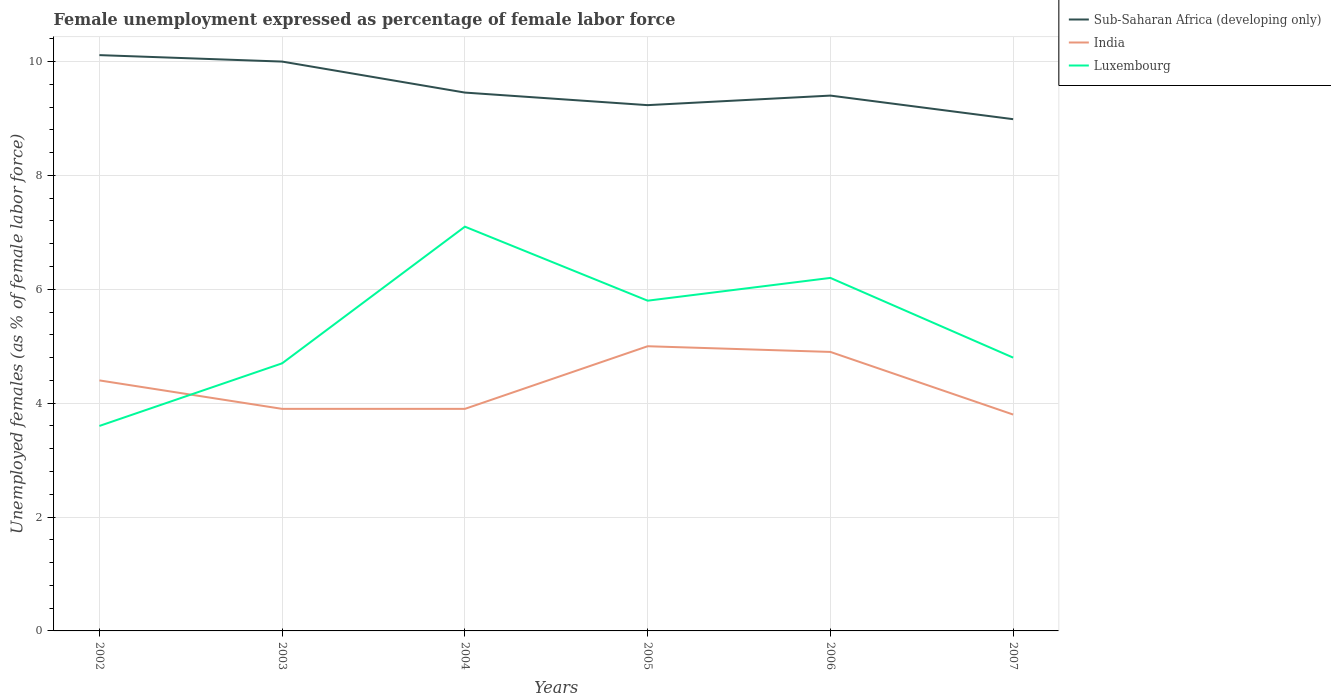Across all years, what is the maximum unemployment in females in in India?
Provide a succinct answer. 3.8. What is the total unemployment in females in in India in the graph?
Offer a very short reply. 0.5. What is the difference between the highest and the second highest unemployment in females in in Luxembourg?
Keep it short and to the point. 3.5. What is the difference between the highest and the lowest unemployment in females in in Luxembourg?
Your response must be concise. 3. Is the unemployment in females in in India strictly greater than the unemployment in females in in Sub-Saharan Africa (developing only) over the years?
Make the answer very short. Yes. How many lines are there?
Give a very brief answer. 3. How many years are there in the graph?
Ensure brevity in your answer.  6. Does the graph contain grids?
Your answer should be compact. Yes. Where does the legend appear in the graph?
Your answer should be very brief. Top right. How are the legend labels stacked?
Your answer should be compact. Vertical. What is the title of the graph?
Offer a terse response. Female unemployment expressed as percentage of female labor force. Does "Trinidad and Tobago" appear as one of the legend labels in the graph?
Offer a terse response. No. What is the label or title of the Y-axis?
Offer a very short reply. Unemployed females (as % of female labor force). What is the Unemployed females (as % of female labor force) in Sub-Saharan Africa (developing only) in 2002?
Provide a succinct answer. 10.11. What is the Unemployed females (as % of female labor force) of India in 2002?
Keep it short and to the point. 4.4. What is the Unemployed females (as % of female labor force) in Luxembourg in 2002?
Provide a short and direct response. 3.6. What is the Unemployed females (as % of female labor force) in Sub-Saharan Africa (developing only) in 2003?
Offer a very short reply. 10. What is the Unemployed females (as % of female labor force) in India in 2003?
Provide a short and direct response. 3.9. What is the Unemployed females (as % of female labor force) of Luxembourg in 2003?
Offer a terse response. 4.7. What is the Unemployed females (as % of female labor force) in Sub-Saharan Africa (developing only) in 2004?
Your answer should be very brief. 9.46. What is the Unemployed females (as % of female labor force) in India in 2004?
Offer a terse response. 3.9. What is the Unemployed females (as % of female labor force) in Luxembourg in 2004?
Ensure brevity in your answer.  7.1. What is the Unemployed females (as % of female labor force) of Sub-Saharan Africa (developing only) in 2005?
Provide a short and direct response. 9.23. What is the Unemployed females (as % of female labor force) in Luxembourg in 2005?
Offer a terse response. 5.8. What is the Unemployed females (as % of female labor force) of Sub-Saharan Africa (developing only) in 2006?
Make the answer very short. 9.4. What is the Unemployed females (as % of female labor force) of India in 2006?
Offer a terse response. 4.9. What is the Unemployed females (as % of female labor force) of Luxembourg in 2006?
Ensure brevity in your answer.  6.2. What is the Unemployed females (as % of female labor force) in Sub-Saharan Africa (developing only) in 2007?
Your answer should be compact. 8.99. What is the Unemployed females (as % of female labor force) in India in 2007?
Offer a terse response. 3.8. What is the Unemployed females (as % of female labor force) in Luxembourg in 2007?
Give a very brief answer. 4.8. Across all years, what is the maximum Unemployed females (as % of female labor force) in Sub-Saharan Africa (developing only)?
Your answer should be very brief. 10.11. Across all years, what is the maximum Unemployed females (as % of female labor force) in India?
Your answer should be very brief. 5. Across all years, what is the maximum Unemployed females (as % of female labor force) of Luxembourg?
Offer a terse response. 7.1. Across all years, what is the minimum Unemployed females (as % of female labor force) of Sub-Saharan Africa (developing only)?
Give a very brief answer. 8.99. Across all years, what is the minimum Unemployed females (as % of female labor force) of India?
Provide a short and direct response. 3.8. Across all years, what is the minimum Unemployed females (as % of female labor force) in Luxembourg?
Your answer should be compact. 3.6. What is the total Unemployed females (as % of female labor force) in Sub-Saharan Africa (developing only) in the graph?
Your response must be concise. 57.19. What is the total Unemployed females (as % of female labor force) in India in the graph?
Give a very brief answer. 25.9. What is the total Unemployed females (as % of female labor force) of Luxembourg in the graph?
Ensure brevity in your answer.  32.2. What is the difference between the Unemployed females (as % of female labor force) of Sub-Saharan Africa (developing only) in 2002 and that in 2003?
Your answer should be very brief. 0.11. What is the difference between the Unemployed females (as % of female labor force) in Luxembourg in 2002 and that in 2003?
Offer a very short reply. -1.1. What is the difference between the Unemployed females (as % of female labor force) in Sub-Saharan Africa (developing only) in 2002 and that in 2004?
Provide a succinct answer. 0.66. What is the difference between the Unemployed females (as % of female labor force) of India in 2002 and that in 2004?
Give a very brief answer. 0.5. What is the difference between the Unemployed females (as % of female labor force) of Sub-Saharan Africa (developing only) in 2002 and that in 2005?
Make the answer very short. 0.88. What is the difference between the Unemployed females (as % of female labor force) of India in 2002 and that in 2005?
Provide a succinct answer. -0.6. What is the difference between the Unemployed females (as % of female labor force) in Sub-Saharan Africa (developing only) in 2002 and that in 2006?
Ensure brevity in your answer.  0.71. What is the difference between the Unemployed females (as % of female labor force) in India in 2002 and that in 2006?
Offer a terse response. -0.5. What is the difference between the Unemployed females (as % of female labor force) of Sub-Saharan Africa (developing only) in 2003 and that in 2004?
Your answer should be very brief. 0.54. What is the difference between the Unemployed females (as % of female labor force) of India in 2003 and that in 2004?
Offer a terse response. 0. What is the difference between the Unemployed females (as % of female labor force) of Sub-Saharan Africa (developing only) in 2003 and that in 2005?
Give a very brief answer. 0.77. What is the difference between the Unemployed females (as % of female labor force) of Luxembourg in 2003 and that in 2005?
Your answer should be compact. -1.1. What is the difference between the Unemployed females (as % of female labor force) of Sub-Saharan Africa (developing only) in 2003 and that in 2006?
Ensure brevity in your answer.  0.6. What is the difference between the Unemployed females (as % of female labor force) in India in 2003 and that in 2006?
Provide a succinct answer. -1. What is the difference between the Unemployed females (as % of female labor force) in Luxembourg in 2003 and that in 2006?
Make the answer very short. -1.5. What is the difference between the Unemployed females (as % of female labor force) of Sub-Saharan Africa (developing only) in 2003 and that in 2007?
Give a very brief answer. 1.01. What is the difference between the Unemployed females (as % of female labor force) in Luxembourg in 2003 and that in 2007?
Give a very brief answer. -0.1. What is the difference between the Unemployed females (as % of female labor force) of Sub-Saharan Africa (developing only) in 2004 and that in 2005?
Ensure brevity in your answer.  0.22. What is the difference between the Unemployed females (as % of female labor force) of India in 2004 and that in 2005?
Offer a very short reply. -1.1. What is the difference between the Unemployed females (as % of female labor force) in Luxembourg in 2004 and that in 2005?
Keep it short and to the point. 1.3. What is the difference between the Unemployed females (as % of female labor force) of Sub-Saharan Africa (developing only) in 2004 and that in 2006?
Provide a short and direct response. 0.05. What is the difference between the Unemployed females (as % of female labor force) of Sub-Saharan Africa (developing only) in 2004 and that in 2007?
Your answer should be compact. 0.47. What is the difference between the Unemployed females (as % of female labor force) of India in 2004 and that in 2007?
Offer a terse response. 0.1. What is the difference between the Unemployed females (as % of female labor force) of Sub-Saharan Africa (developing only) in 2005 and that in 2006?
Ensure brevity in your answer.  -0.17. What is the difference between the Unemployed females (as % of female labor force) in Sub-Saharan Africa (developing only) in 2005 and that in 2007?
Ensure brevity in your answer.  0.25. What is the difference between the Unemployed females (as % of female labor force) of India in 2005 and that in 2007?
Ensure brevity in your answer.  1.2. What is the difference between the Unemployed females (as % of female labor force) in Sub-Saharan Africa (developing only) in 2006 and that in 2007?
Offer a terse response. 0.41. What is the difference between the Unemployed females (as % of female labor force) of Luxembourg in 2006 and that in 2007?
Offer a very short reply. 1.4. What is the difference between the Unemployed females (as % of female labor force) in Sub-Saharan Africa (developing only) in 2002 and the Unemployed females (as % of female labor force) in India in 2003?
Make the answer very short. 6.21. What is the difference between the Unemployed females (as % of female labor force) of Sub-Saharan Africa (developing only) in 2002 and the Unemployed females (as % of female labor force) of Luxembourg in 2003?
Your response must be concise. 5.41. What is the difference between the Unemployed females (as % of female labor force) in Sub-Saharan Africa (developing only) in 2002 and the Unemployed females (as % of female labor force) in India in 2004?
Provide a short and direct response. 6.21. What is the difference between the Unemployed females (as % of female labor force) of Sub-Saharan Africa (developing only) in 2002 and the Unemployed females (as % of female labor force) of Luxembourg in 2004?
Give a very brief answer. 3.01. What is the difference between the Unemployed females (as % of female labor force) of India in 2002 and the Unemployed females (as % of female labor force) of Luxembourg in 2004?
Ensure brevity in your answer.  -2.7. What is the difference between the Unemployed females (as % of female labor force) of Sub-Saharan Africa (developing only) in 2002 and the Unemployed females (as % of female labor force) of India in 2005?
Provide a short and direct response. 5.11. What is the difference between the Unemployed females (as % of female labor force) of Sub-Saharan Africa (developing only) in 2002 and the Unemployed females (as % of female labor force) of Luxembourg in 2005?
Provide a succinct answer. 4.31. What is the difference between the Unemployed females (as % of female labor force) in India in 2002 and the Unemployed females (as % of female labor force) in Luxembourg in 2005?
Provide a short and direct response. -1.4. What is the difference between the Unemployed females (as % of female labor force) in Sub-Saharan Africa (developing only) in 2002 and the Unemployed females (as % of female labor force) in India in 2006?
Provide a succinct answer. 5.21. What is the difference between the Unemployed females (as % of female labor force) of Sub-Saharan Africa (developing only) in 2002 and the Unemployed females (as % of female labor force) of Luxembourg in 2006?
Make the answer very short. 3.91. What is the difference between the Unemployed females (as % of female labor force) of India in 2002 and the Unemployed females (as % of female labor force) of Luxembourg in 2006?
Provide a short and direct response. -1.8. What is the difference between the Unemployed females (as % of female labor force) of Sub-Saharan Africa (developing only) in 2002 and the Unemployed females (as % of female labor force) of India in 2007?
Give a very brief answer. 6.31. What is the difference between the Unemployed females (as % of female labor force) in Sub-Saharan Africa (developing only) in 2002 and the Unemployed females (as % of female labor force) in Luxembourg in 2007?
Offer a terse response. 5.31. What is the difference between the Unemployed females (as % of female labor force) of India in 2002 and the Unemployed females (as % of female labor force) of Luxembourg in 2007?
Your response must be concise. -0.4. What is the difference between the Unemployed females (as % of female labor force) of Sub-Saharan Africa (developing only) in 2003 and the Unemployed females (as % of female labor force) of India in 2004?
Offer a terse response. 6.1. What is the difference between the Unemployed females (as % of female labor force) of Sub-Saharan Africa (developing only) in 2003 and the Unemployed females (as % of female labor force) of Luxembourg in 2004?
Give a very brief answer. 2.9. What is the difference between the Unemployed females (as % of female labor force) in India in 2003 and the Unemployed females (as % of female labor force) in Luxembourg in 2004?
Provide a short and direct response. -3.2. What is the difference between the Unemployed females (as % of female labor force) of Sub-Saharan Africa (developing only) in 2003 and the Unemployed females (as % of female labor force) of India in 2005?
Your answer should be compact. 5. What is the difference between the Unemployed females (as % of female labor force) in Sub-Saharan Africa (developing only) in 2003 and the Unemployed females (as % of female labor force) in Luxembourg in 2005?
Offer a very short reply. 4.2. What is the difference between the Unemployed females (as % of female labor force) of Sub-Saharan Africa (developing only) in 2003 and the Unemployed females (as % of female labor force) of India in 2006?
Your answer should be very brief. 5.1. What is the difference between the Unemployed females (as % of female labor force) of Sub-Saharan Africa (developing only) in 2003 and the Unemployed females (as % of female labor force) of Luxembourg in 2006?
Make the answer very short. 3.8. What is the difference between the Unemployed females (as % of female labor force) in Sub-Saharan Africa (developing only) in 2003 and the Unemployed females (as % of female labor force) in India in 2007?
Offer a very short reply. 6.2. What is the difference between the Unemployed females (as % of female labor force) of Sub-Saharan Africa (developing only) in 2003 and the Unemployed females (as % of female labor force) of Luxembourg in 2007?
Provide a short and direct response. 5.2. What is the difference between the Unemployed females (as % of female labor force) in India in 2003 and the Unemployed females (as % of female labor force) in Luxembourg in 2007?
Your response must be concise. -0.9. What is the difference between the Unemployed females (as % of female labor force) in Sub-Saharan Africa (developing only) in 2004 and the Unemployed females (as % of female labor force) in India in 2005?
Ensure brevity in your answer.  4.46. What is the difference between the Unemployed females (as % of female labor force) of Sub-Saharan Africa (developing only) in 2004 and the Unemployed females (as % of female labor force) of Luxembourg in 2005?
Provide a succinct answer. 3.66. What is the difference between the Unemployed females (as % of female labor force) in Sub-Saharan Africa (developing only) in 2004 and the Unemployed females (as % of female labor force) in India in 2006?
Give a very brief answer. 4.56. What is the difference between the Unemployed females (as % of female labor force) in Sub-Saharan Africa (developing only) in 2004 and the Unemployed females (as % of female labor force) in Luxembourg in 2006?
Your response must be concise. 3.26. What is the difference between the Unemployed females (as % of female labor force) in India in 2004 and the Unemployed females (as % of female labor force) in Luxembourg in 2006?
Give a very brief answer. -2.3. What is the difference between the Unemployed females (as % of female labor force) of Sub-Saharan Africa (developing only) in 2004 and the Unemployed females (as % of female labor force) of India in 2007?
Offer a terse response. 5.66. What is the difference between the Unemployed females (as % of female labor force) in Sub-Saharan Africa (developing only) in 2004 and the Unemployed females (as % of female labor force) in Luxembourg in 2007?
Give a very brief answer. 4.66. What is the difference between the Unemployed females (as % of female labor force) of Sub-Saharan Africa (developing only) in 2005 and the Unemployed females (as % of female labor force) of India in 2006?
Offer a terse response. 4.33. What is the difference between the Unemployed females (as % of female labor force) of Sub-Saharan Africa (developing only) in 2005 and the Unemployed females (as % of female labor force) of Luxembourg in 2006?
Your answer should be very brief. 3.03. What is the difference between the Unemployed females (as % of female labor force) in India in 2005 and the Unemployed females (as % of female labor force) in Luxembourg in 2006?
Provide a succinct answer. -1.2. What is the difference between the Unemployed females (as % of female labor force) of Sub-Saharan Africa (developing only) in 2005 and the Unemployed females (as % of female labor force) of India in 2007?
Ensure brevity in your answer.  5.43. What is the difference between the Unemployed females (as % of female labor force) in Sub-Saharan Africa (developing only) in 2005 and the Unemployed females (as % of female labor force) in Luxembourg in 2007?
Keep it short and to the point. 4.43. What is the difference between the Unemployed females (as % of female labor force) of India in 2005 and the Unemployed females (as % of female labor force) of Luxembourg in 2007?
Offer a very short reply. 0.2. What is the difference between the Unemployed females (as % of female labor force) in Sub-Saharan Africa (developing only) in 2006 and the Unemployed females (as % of female labor force) in India in 2007?
Your answer should be very brief. 5.6. What is the difference between the Unemployed females (as % of female labor force) of Sub-Saharan Africa (developing only) in 2006 and the Unemployed females (as % of female labor force) of Luxembourg in 2007?
Keep it short and to the point. 4.6. What is the average Unemployed females (as % of female labor force) in Sub-Saharan Africa (developing only) per year?
Your answer should be compact. 9.53. What is the average Unemployed females (as % of female labor force) in India per year?
Offer a terse response. 4.32. What is the average Unemployed females (as % of female labor force) in Luxembourg per year?
Give a very brief answer. 5.37. In the year 2002, what is the difference between the Unemployed females (as % of female labor force) in Sub-Saharan Africa (developing only) and Unemployed females (as % of female labor force) in India?
Your answer should be compact. 5.71. In the year 2002, what is the difference between the Unemployed females (as % of female labor force) of Sub-Saharan Africa (developing only) and Unemployed females (as % of female labor force) of Luxembourg?
Make the answer very short. 6.51. In the year 2003, what is the difference between the Unemployed females (as % of female labor force) in Sub-Saharan Africa (developing only) and Unemployed females (as % of female labor force) in India?
Offer a terse response. 6.1. In the year 2003, what is the difference between the Unemployed females (as % of female labor force) in Sub-Saharan Africa (developing only) and Unemployed females (as % of female labor force) in Luxembourg?
Your answer should be compact. 5.3. In the year 2003, what is the difference between the Unemployed females (as % of female labor force) of India and Unemployed females (as % of female labor force) of Luxembourg?
Provide a succinct answer. -0.8. In the year 2004, what is the difference between the Unemployed females (as % of female labor force) in Sub-Saharan Africa (developing only) and Unemployed females (as % of female labor force) in India?
Offer a very short reply. 5.56. In the year 2004, what is the difference between the Unemployed females (as % of female labor force) in Sub-Saharan Africa (developing only) and Unemployed females (as % of female labor force) in Luxembourg?
Give a very brief answer. 2.36. In the year 2004, what is the difference between the Unemployed females (as % of female labor force) in India and Unemployed females (as % of female labor force) in Luxembourg?
Make the answer very short. -3.2. In the year 2005, what is the difference between the Unemployed females (as % of female labor force) in Sub-Saharan Africa (developing only) and Unemployed females (as % of female labor force) in India?
Make the answer very short. 4.23. In the year 2005, what is the difference between the Unemployed females (as % of female labor force) of Sub-Saharan Africa (developing only) and Unemployed females (as % of female labor force) of Luxembourg?
Provide a short and direct response. 3.43. In the year 2006, what is the difference between the Unemployed females (as % of female labor force) of Sub-Saharan Africa (developing only) and Unemployed females (as % of female labor force) of India?
Your response must be concise. 4.5. In the year 2006, what is the difference between the Unemployed females (as % of female labor force) of Sub-Saharan Africa (developing only) and Unemployed females (as % of female labor force) of Luxembourg?
Offer a very short reply. 3.2. In the year 2007, what is the difference between the Unemployed females (as % of female labor force) of Sub-Saharan Africa (developing only) and Unemployed females (as % of female labor force) of India?
Keep it short and to the point. 5.19. In the year 2007, what is the difference between the Unemployed females (as % of female labor force) of Sub-Saharan Africa (developing only) and Unemployed females (as % of female labor force) of Luxembourg?
Offer a terse response. 4.19. What is the ratio of the Unemployed females (as % of female labor force) of Sub-Saharan Africa (developing only) in 2002 to that in 2003?
Keep it short and to the point. 1.01. What is the ratio of the Unemployed females (as % of female labor force) of India in 2002 to that in 2003?
Provide a short and direct response. 1.13. What is the ratio of the Unemployed females (as % of female labor force) in Luxembourg in 2002 to that in 2003?
Your response must be concise. 0.77. What is the ratio of the Unemployed females (as % of female labor force) in Sub-Saharan Africa (developing only) in 2002 to that in 2004?
Provide a succinct answer. 1.07. What is the ratio of the Unemployed females (as % of female labor force) in India in 2002 to that in 2004?
Provide a short and direct response. 1.13. What is the ratio of the Unemployed females (as % of female labor force) in Luxembourg in 2002 to that in 2004?
Your response must be concise. 0.51. What is the ratio of the Unemployed females (as % of female labor force) of Sub-Saharan Africa (developing only) in 2002 to that in 2005?
Give a very brief answer. 1.1. What is the ratio of the Unemployed females (as % of female labor force) in Luxembourg in 2002 to that in 2005?
Provide a succinct answer. 0.62. What is the ratio of the Unemployed females (as % of female labor force) of Sub-Saharan Africa (developing only) in 2002 to that in 2006?
Offer a very short reply. 1.08. What is the ratio of the Unemployed females (as % of female labor force) in India in 2002 to that in 2006?
Your answer should be very brief. 0.9. What is the ratio of the Unemployed females (as % of female labor force) of Luxembourg in 2002 to that in 2006?
Make the answer very short. 0.58. What is the ratio of the Unemployed females (as % of female labor force) of Sub-Saharan Africa (developing only) in 2002 to that in 2007?
Keep it short and to the point. 1.13. What is the ratio of the Unemployed females (as % of female labor force) in India in 2002 to that in 2007?
Your answer should be compact. 1.16. What is the ratio of the Unemployed females (as % of female labor force) of Sub-Saharan Africa (developing only) in 2003 to that in 2004?
Offer a terse response. 1.06. What is the ratio of the Unemployed females (as % of female labor force) in Luxembourg in 2003 to that in 2004?
Your answer should be compact. 0.66. What is the ratio of the Unemployed females (as % of female labor force) of Sub-Saharan Africa (developing only) in 2003 to that in 2005?
Provide a short and direct response. 1.08. What is the ratio of the Unemployed females (as % of female labor force) in India in 2003 to that in 2005?
Offer a terse response. 0.78. What is the ratio of the Unemployed females (as % of female labor force) in Luxembourg in 2003 to that in 2005?
Offer a very short reply. 0.81. What is the ratio of the Unemployed females (as % of female labor force) in Sub-Saharan Africa (developing only) in 2003 to that in 2006?
Provide a succinct answer. 1.06. What is the ratio of the Unemployed females (as % of female labor force) in India in 2003 to that in 2006?
Offer a terse response. 0.8. What is the ratio of the Unemployed females (as % of female labor force) in Luxembourg in 2003 to that in 2006?
Offer a terse response. 0.76. What is the ratio of the Unemployed females (as % of female labor force) in Sub-Saharan Africa (developing only) in 2003 to that in 2007?
Give a very brief answer. 1.11. What is the ratio of the Unemployed females (as % of female labor force) of India in 2003 to that in 2007?
Make the answer very short. 1.03. What is the ratio of the Unemployed females (as % of female labor force) of Luxembourg in 2003 to that in 2007?
Offer a terse response. 0.98. What is the ratio of the Unemployed females (as % of female labor force) of Sub-Saharan Africa (developing only) in 2004 to that in 2005?
Ensure brevity in your answer.  1.02. What is the ratio of the Unemployed females (as % of female labor force) of India in 2004 to that in 2005?
Your answer should be very brief. 0.78. What is the ratio of the Unemployed females (as % of female labor force) of Luxembourg in 2004 to that in 2005?
Your response must be concise. 1.22. What is the ratio of the Unemployed females (as % of female labor force) in Sub-Saharan Africa (developing only) in 2004 to that in 2006?
Offer a terse response. 1.01. What is the ratio of the Unemployed females (as % of female labor force) in India in 2004 to that in 2006?
Give a very brief answer. 0.8. What is the ratio of the Unemployed females (as % of female labor force) of Luxembourg in 2004 to that in 2006?
Keep it short and to the point. 1.15. What is the ratio of the Unemployed females (as % of female labor force) of Sub-Saharan Africa (developing only) in 2004 to that in 2007?
Your response must be concise. 1.05. What is the ratio of the Unemployed females (as % of female labor force) of India in 2004 to that in 2007?
Make the answer very short. 1.03. What is the ratio of the Unemployed females (as % of female labor force) in Luxembourg in 2004 to that in 2007?
Offer a very short reply. 1.48. What is the ratio of the Unemployed females (as % of female labor force) in Sub-Saharan Africa (developing only) in 2005 to that in 2006?
Provide a succinct answer. 0.98. What is the ratio of the Unemployed females (as % of female labor force) of India in 2005 to that in 2006?
Your response must be concise. 1.02. What is the ratio of the Unemployed females (as % of female labor force) in Luxembourg in 2005 to that in 2006?
Offer a terse response. 0.94. What is the ratio of the Unemployed females (as % of female labor force) of Sub-Saharan Africa (developing only) in 2005 to that in 2007?
Your answer should be very brief. 1.03. What is the ratio of the Unemployed females (as % of female labor force) of India in 2005 to that in 2007?
Provide a short and direct response. 1.32. What is the ratio of the Unemployed females (as % of female labor force) in Luxembourg in 2005 to that in 2007?
Your response must be concise. 1.21. What is the ratio of the Unemployed females (as % of female labor force) in Sub-Saharan Africa (developing only) in 2006 to that in 2007?
Keep it short and to the point. 1.05. What is the ratio of the Unemployed females (as % of female labor force) in India in 2006 to that in 2007?
Provide a short and direct response. 1.29. What is the ratio of the Unemployed females (as % of female labor force) of Luxembourg in 2006 to that in 2007?
Provide a short and direct response. 1.29. What is the difference between the highest and the second highest Unemployed females (as % of female labor force) in Sub-Saharan Africa (developing only)?
Your answer should be compact. 0.11. What is the difference between the highest and the second highest Unemployed females (as % of female labor force) of India?
Your response must be concise. 0.1. What is the difference between the highest and the second highest Unemployed females (as % of female labor force) in Luxembourg?
Offer a very short reply. 0.9. What is the difference between the highest and the lowest Unemployed females (as % of female labor force) in Sub-Saharan Africa (developing only)?
Keep it short and to the point. 1.12. What is the difference between the highest and the lowest Unemployed females (as % of female labor force) of India?
Your answer should be very brief. 1.2. What is the difference between the highest and the lowest Unemployed females (as % of female labor force) in Luxembourg?
Give a very brief answer. 3.5. 